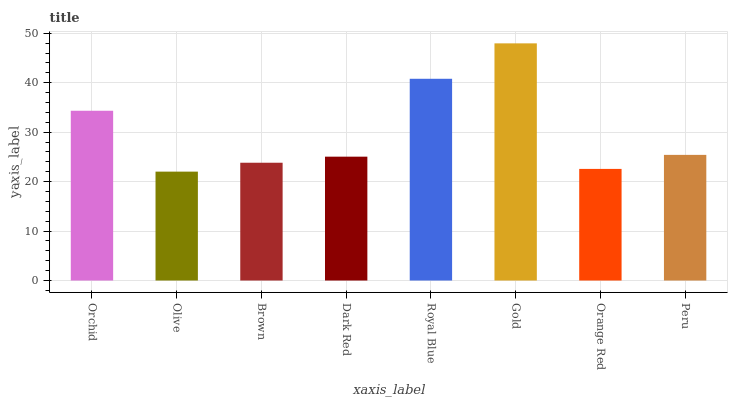Is Olive the minimum?
Answer yes or no. Yes. Is Gold the maximum?
Answer yes or no. Yes. Is Brown the minimum?
Answer yes or no. No. Is Brown the maximum?
Answer yes or no. No. Is Brown greater than Olive?
Answer yes or no. Yes. Is Olive less than Brown?
Answer yes or no. Yes. Is Olive greater than Brown?
Answer yes or no. No. Is Brown less than Olive?
Answer yes or no. No. Is Peru the high median?
Answer yes or no. Yes. Is Dark Red the low median?
Answer yes or no. Yes. Is Gold the high median?
Answer yes or no. No. Is Peru the low median?
Answer yes or no. No. 